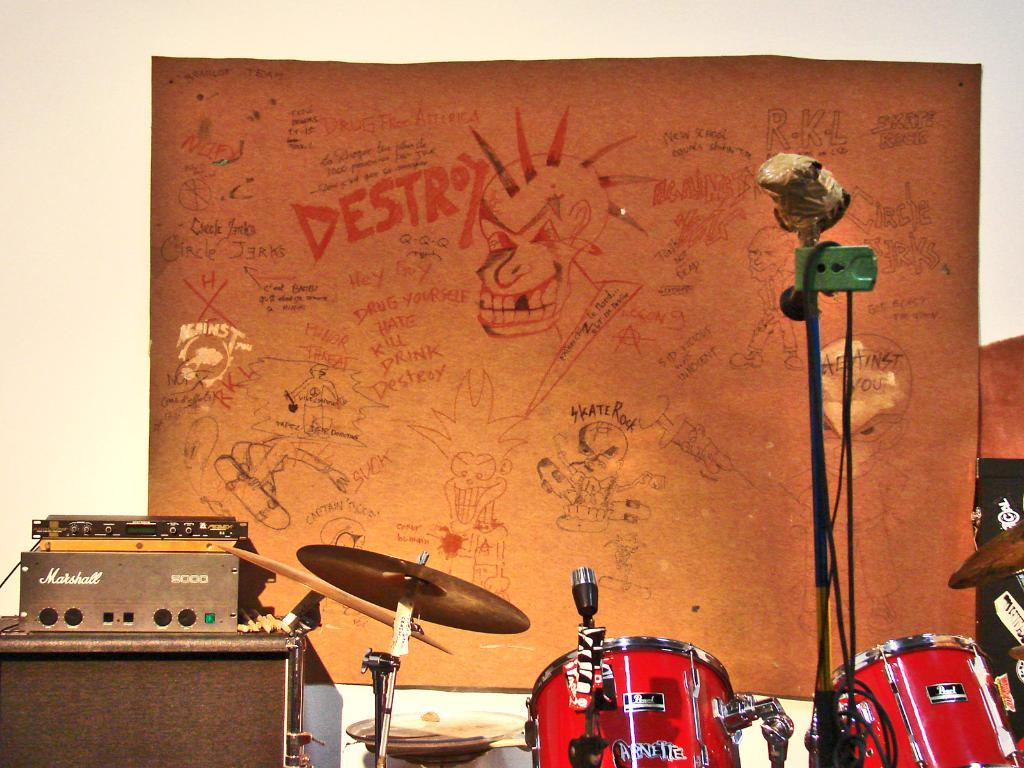<image>
Give a short and clear explanation of the subsequent image. A drum set is placed in front of a large poster with drawings on it and graffiti words one saying destroy. 